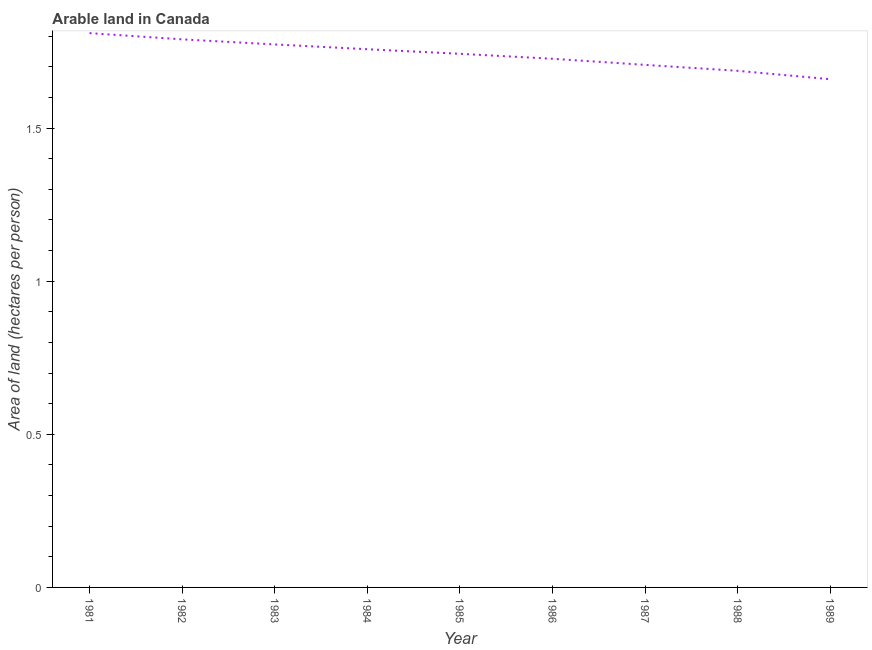What is the area of arable land in 1984?
Ensure brevity in your answer.  1.76. Across all years, what is the maximum area of arable land?
Provide a succinct answer. 1.81. Across all years, what is the minimum area of arable land?
Give a very brief answer. 1.66. In which year was the area of arable land maximum?
Provide a succinct answer. 1981. In which year was the area of arable land minimum?
Ensure brevity in your answer.  1989. What is the sum of the area of arable land?
Provide a short and direct response. 15.65. What is the difference between the area of arable land in 1986 and 1988?
Make the answer very short. 0.04. What is the average area of arable land per year?
Ensure brevity in your answer.  1.74. What is the median area of arable land?
Your response must be concise. 1.74. In how many years, is the area of arable land greater than 0.8 hectares per person?
Ensure brevity in your answer.  9. Do a majority of the years between 1989 and 1988 (inclusive) have area of arable land greater than 1.5 hectares per person?
Provide a succinct answer. No. What is the ratio of the area of arable land in 1981 to that in 1987?
Your answer should be compact. 1.06. What is the difference between the highest and the second highest area of arable land?
Your answer should be compact. 0.02. Is the sum of the area of arable land in 1984 and 1987 greater than the maximum area of arable land across all years?
Keep it short and to the point. Yes. What is the difference between the highest and the lowest area of arable land?
Provide a succinct answer. 0.15. In how many years, is the area of arable land greater than the average area of arable land taken over all years?
Give a very brief answer. 5. Does the area of arable land monotonically increase over the years?
Your answer should be compact. No. How many years are there in the graph?
Your answer should be compact. 9. Are the values on the major ticks of Y-axis written in scientific E-notation?
Give a very brief answer. No. Does the graph contain any zero values?
Your response must be concise. No. What is the title of the graph?
Make the answer very short. Arable land in Canada. What is the label or title of the Y-axis?
Keep it short and to the point. Area of land (hectares per person). What is the Area of land (hectares per person) of 1981?
Keep it short and to the point. 1.81. What is the Area of land (hectares per person) of 1982?
Make the answer very short. 1.79. What is the Area of land (hectares per person) of 1983?
Offer a terse response. 1.77. What is the Area of land (hectares per person) in 1984?
Your answer should be very brief. 1.76. What is the Area of land (hectares per person) of 1985?
Provide a succinct answer. 1.74. What is the Area of land (hectares per person) in 1986?
Ensure brevity in your answer.  1.73. What is the Area of land (hectares per person) in 1987?
Your response must be concise. 1.71. What is the Area of land (hectares per person) in 1988?
Your answer should be compact. 1.69. What is the Area of land (hectares per person) of 1989?
Ensure brevity in your answer.  1.66. What is the difference between the Area of land (hectares per person) in 1981 and 1982?
Provide a short and direct response. 0.02. What is the difference between the Area of land (hectares per person) in 1981 and 1983?
Make the answer very short. 0.04. What is the difference between the Area of land (hectares per person) in 1981 and 1984?
Ensure brevity in your answer.  0.05. What is the difference between the Area of land (hectares per person) in 1981 and 1985?
Give a very brief answer. 0.07. What is the difference between the Area of land (hectares per person) in 1981 and 1986?
Your answer should be very brief. 0.08. What is the difference between the Area of land (hectares per person) in 1981 and 1987?
Your response must be concise. 0.1. What is the difference between the Area of land (hectares per person) in 1981 and 1988?
Offer a terse response. 0.12. What is the difference between the Area of land (hectares per person) in 1981 and 1989?
Keep it short and to the point. 0.15. What is the difference between the Area of land (hectares per person) in 1982 and 1983?
Keep it short and to the point. 0.02. What is the difference between the Area of land (hectares per person) in 1982 and 1984?
Give a very brief answer. 0.03. What is the difference between the Area of land (hectares per person) in 1982 and 1985?
Ensure brevity in your answer.  0.05. What is the difference between the Area of land (hectares per person) in 1982 and 1986?
Ensure brevity in your answer.  0.06. What is the difference between the Area of land (hectares per person) in 1982 and 1987?
Provide a succinct answer. 0.08. What is the difference between the Area of land (hectares per person) in 1982 and 1988?
Give a very brief answer. 0.1. What is the difference between the Area of land (hectares per person) in 1982 and 1989?
Offer a very short reply. 0.13. What is the difference between the Area of land (hectares per person) in 1983 and 1984?
Provide a short and direct response. 0.02. What is the difference between the Area of land (hectares per person) in 1983 and 1985?
Your answer should be very brief. 0.03. What is the difference between the Area of land (hectares per person) in 1983 and 1986?
Ensure brevity in your answer.  0.05. What is the difference between the Area of land (hectares per person) in 1983 and 1987?
Make the answer very short. 0.07. What is the difference between the Area of land (hectares per person) in 1983 and 1988?
Provide a succinct answer. 0.09. What is the difference between the Area of land (hectares per person) in 1983 and 1989?
Offer a terse response. 0.11. What is the difference between the Area of land (hectares per person) in 1984 and 1985?
Give a very brief answer. 0.01. What is the difference between the Area of land (hectares per person) in 1984 and 1986?
Your response must be concise. 0.03. What is the difference between the Area of land (hectares per person) in 1984 and 1987?
Provide a succinct answer. 0.05. What is the difference between the Area of land (hectares per person) in 1984 and 1988?
Your answer should be compact. 0.07. What is the difference between the Area of land (hectares per person) in 1984 and 1989?
Offer a terse response. 0.1. What is the difference between the Area of land (hectares per person) in 1985 and 1986?
Make the answer very short. 0.02. What is the difference between the Area of land (hectares per person) in 1985 and 1987?
Your answer should be compact. 0.04. What is the difference between the Area of land (hectares per person) in 1985 and 1988?
Provide a short and direct response. 0.06. What is the difference between the Area of land (hectares per person) in 1985 and 1989?
Ensure brevity in your answer.  0.08. What is the difference between the Area of land (hectares per person) in 1986 and 1987?
Make the answer very short. 0.02. What is the difference between the Area of land (hectares per person) in 1986 and 1988?
Your response must be concise. 0.04. What is the difference between the Area of land (hectares per person) in 1986 and 1989?
Provide a short and direct response. 0.07. What is the difference between the Area of land (hectares per person) in 1987 and 1988?
Provide a succinct answer. 0.02. What is the difference between the Area of land (hectares per person) in 1987 and 1989?
Provide a short and direct response. 0.05. What is the difference between the Area of land (hectares per person) in 1988 and 1989?
Offer a very short reply. 0.03. What is the ratio of the Area of land (hectares per person) in 1981 to that in 1982?
Provide a succinct answer. 1.01. What is the ratio of the Area of land (hectares per person) in 1981 to that in 1985?
Ensure brevity in your answer.  1.04. What is the ratio of the Area of land (hectares per person) in 1981 to that in 1986?
Offer a terse response. 1.05. What is the ratio of the Area of land (hectares per person) in 1981 to that in 1987?
Offer a terse response. 1.06. What is the ratio of the Area of land (hectares per person) in 1981 to that in 1988?
Keep it short and to the point. 1.07. What is the ratio of the Area of land (hectares per person) in 1981 to that in 1989?
Offer a terse response. 1.09. What is the ratio of the Area of land (hectares per person) in 1982 to that in 1985?
Provide a short and direct response. 1.03. What is the ratio of the Area of land (hectares per person) in 1982 to that in 1987?
Keep it short and to the point. 1.05. What is the ratio of the Area of land (hectares per person) in 1982 to that in 1988?
Keep it short and to the point. 1.06. What is the ratio of the Area of land (hectares per person) in 1982 to that in 1989?
Your answer should be compact. 1.08. What is the ratio of the Area of land (hectares per person) in 1983 to that in 1984?
Offer a very short reply. 1.01. What is the ratio of the Area of land (hectares per person) in 1983 to that in 1986?
Your response must be concise. 1.03. What is the ratio of the Area of land (hectares per person) in 1983 to that in 1987?
Your response must be concise. 1.04. What is the ratio of the Area of land (hectares per person) in 1983 to that in 1988?
Offer a very short reply. 1.05. What is the ratio of the Area of land (hectares per person) in 1983 to that in 1989?
Make the answer very short. 1.07. What is the ratio of the Area of land (hectares per person) in 1984 to that in 1985?
Give a very brief answer. 1.01. What is the ratio of the Area of land (hectares per person) in 1984 to that in 1987?
Your answer should be very brief. 1.03. What is the ratio of the Area of land (hectares per person) in 1984 to that in 1988?
Provide a short and direct response. 1.04. What is the ratio of the Area of land (hectares per person) in 1984 to that in 1989?
Provide a succinct answer. 1.06. What is the ratio of the Area of land (hectares per person) in 1985 to that in 1988?
Provide a succinct answer. 1.03. What is the ratio of the Area of land (hectares per person) in 1986 to that in 1988?
Ensure brevity in your answer.  1.02. What is the ratio of the Area of land (hectares per person) in 1986 to that in 1989?
Keep it short and to the point. 1.04. What is the ratio of the Area of land (hectares per person) in 1987 to that in 1989?
Your answer should be very brief. 1.03. 